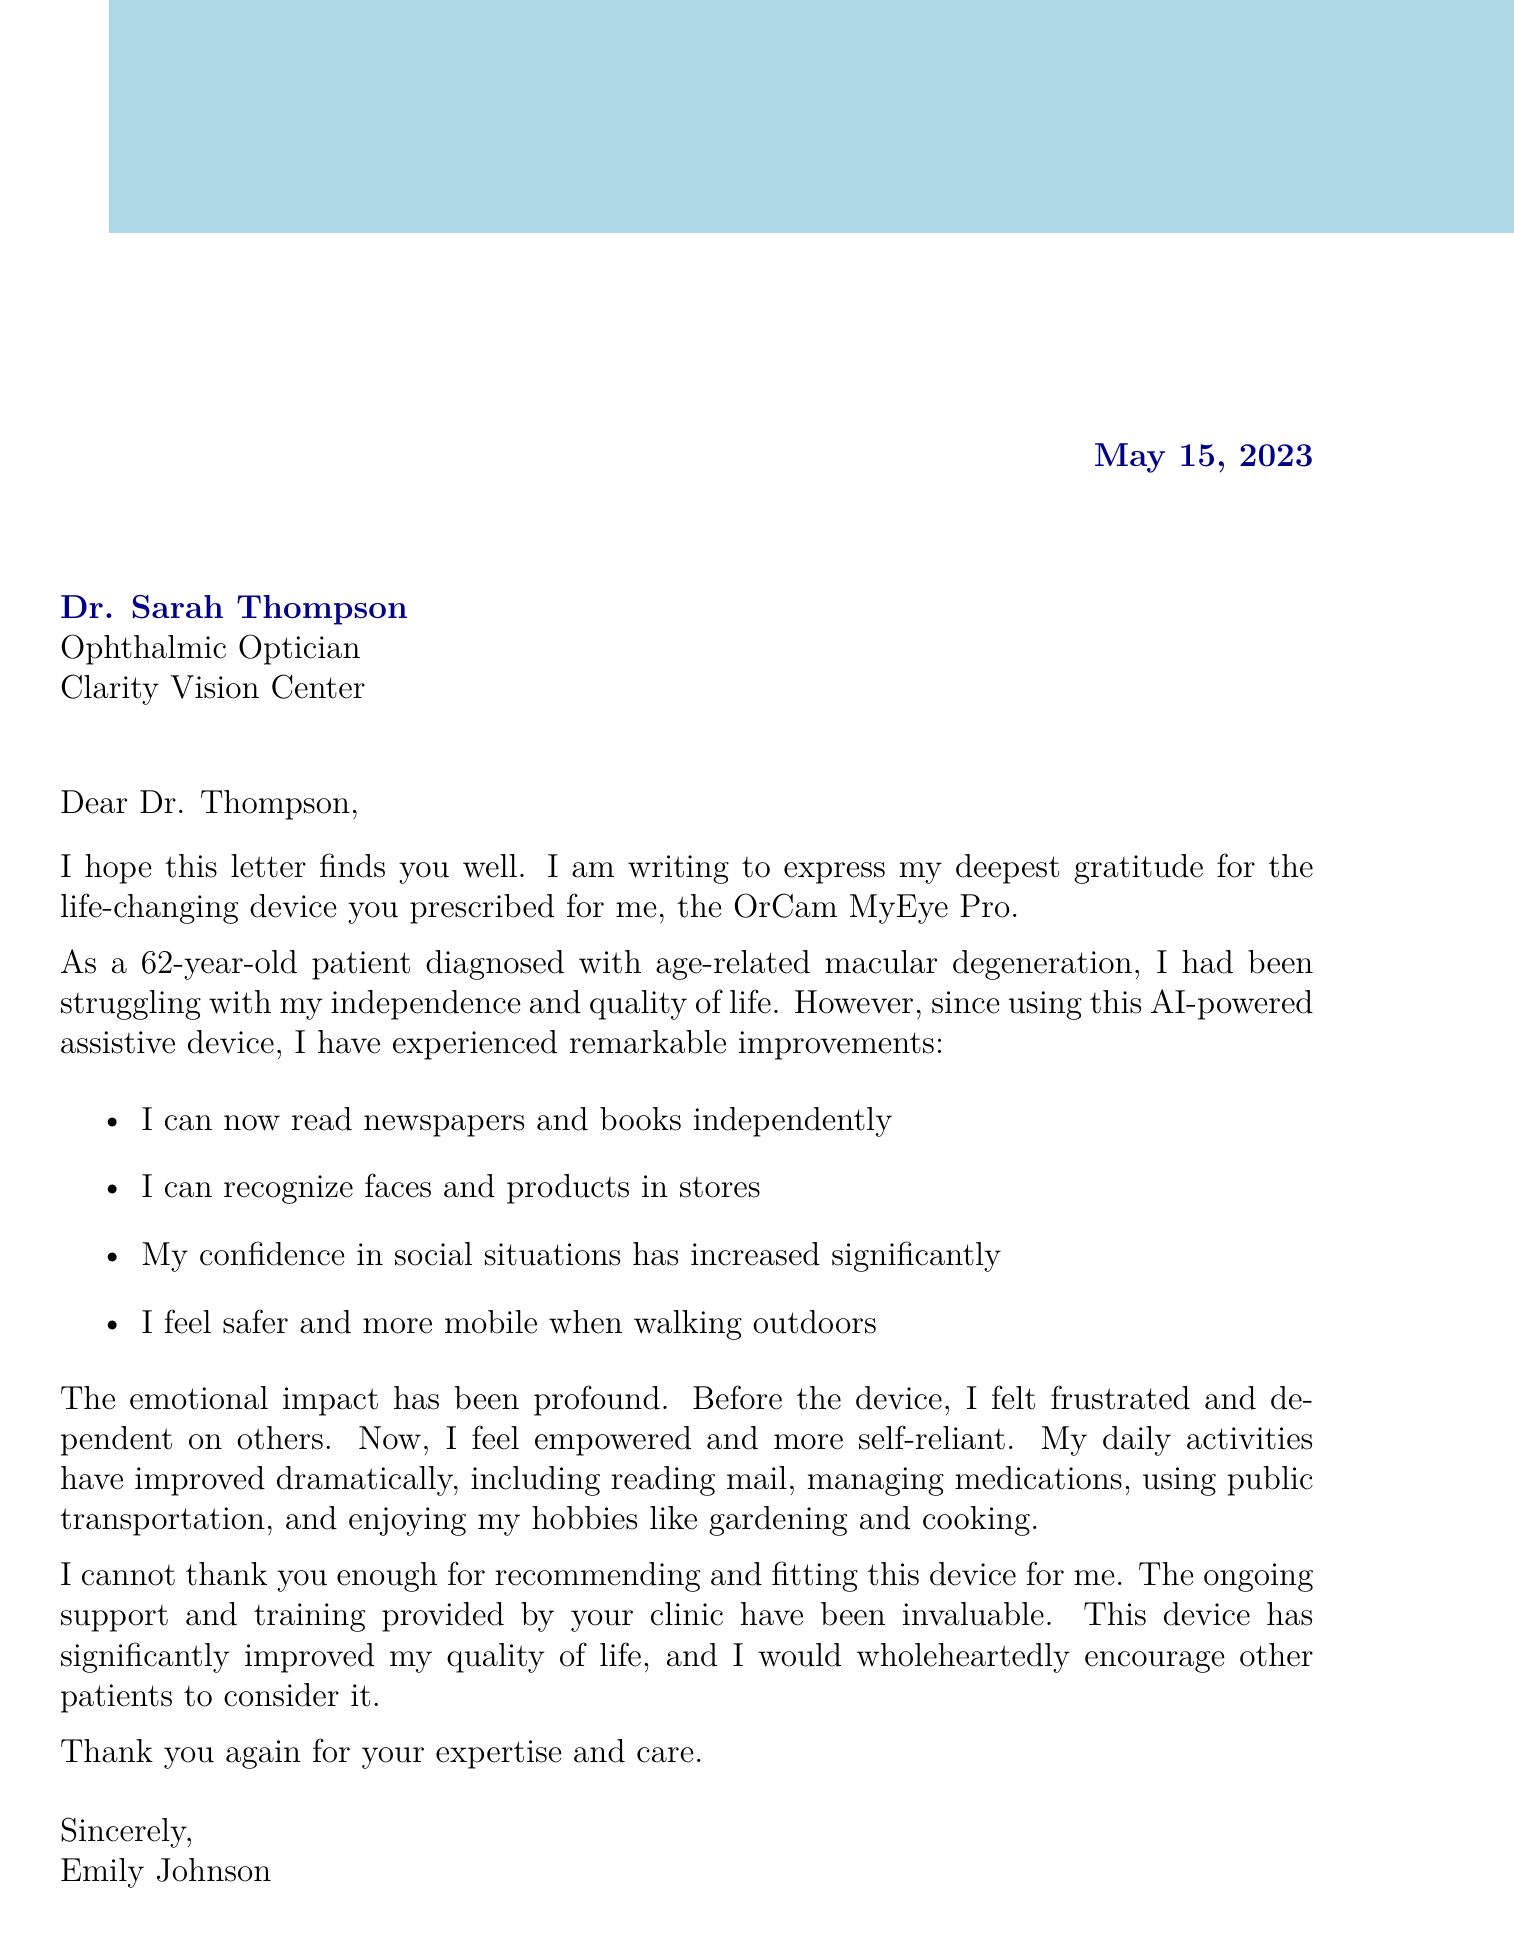What is the date of the letter? The date of the letter is specified at the beginning of the document as May 15, 2023.
Answer: May 15, 2023 Who is the patient? The patient's name is mentioned in the document as Emily Johnson.
Answer: Emily Johnson What device was prescribed to the patient? The document states that the prescribed device is the OrCam MyEye Pro.
Answer: OrCam MyEye Pro What was the patient's emotional state before using the device? The letter describes the patient's emotional state before the device as frustrated and dependent on others.
Answer: Frustrated and dependent on others Which activity improved related to social situations? The patient mentions an improvement in confidence in social situations as one of the benefits experienced after using the device.
Answer: Increased confidence in social situations What type of device is the OrCam MyEye Pro? In the document, the type of the device is classified as a wearable AI-powered assistive device.
Answer: Wearable AI-powered assistive device How old is the patient? The document provides the patient's age as 62 years old.
Answer: 62 What does the patient recommend to other patients? The conclusion of the letter includes a recommendation from the patient encouraging others to consider the device.
Answer: Encourage other patients to consider this device What is the overall impact of the device on the patient's quality of life? The document concludes that the device has significantly improved the patient's quality of life.
Answer: Significantly improved quality of life 